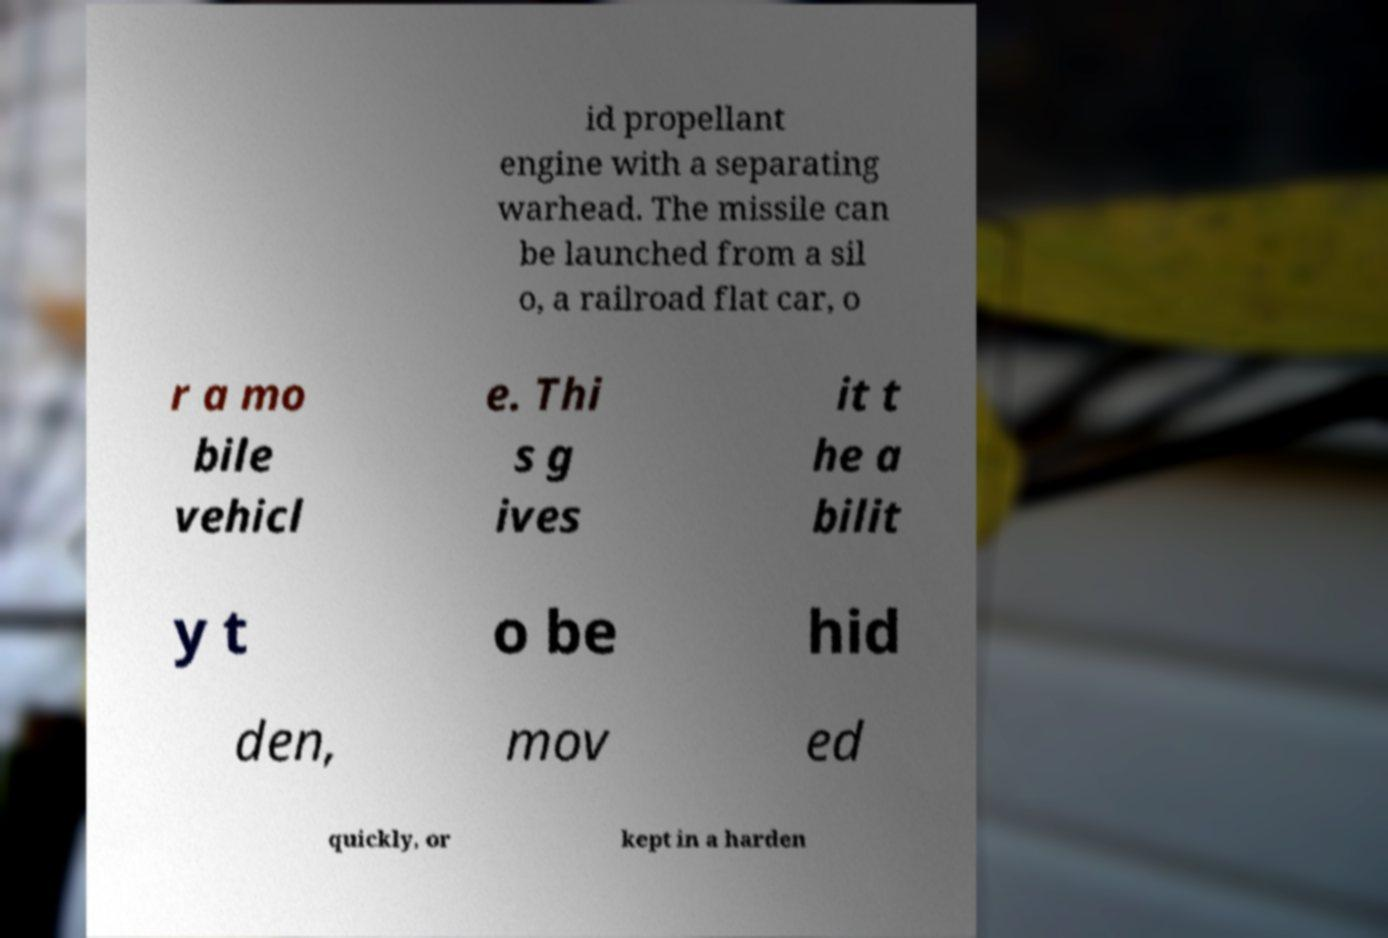Please identify and transcribe the text found in this image. id propellant engine with a separating warhead. The missile can be launched from a sil o, a railroad flat car, o r a mo bile vehicl e. Thi s g ives it t he a bilit y t o be hid den, mov ed quickly, or kept in a harden 